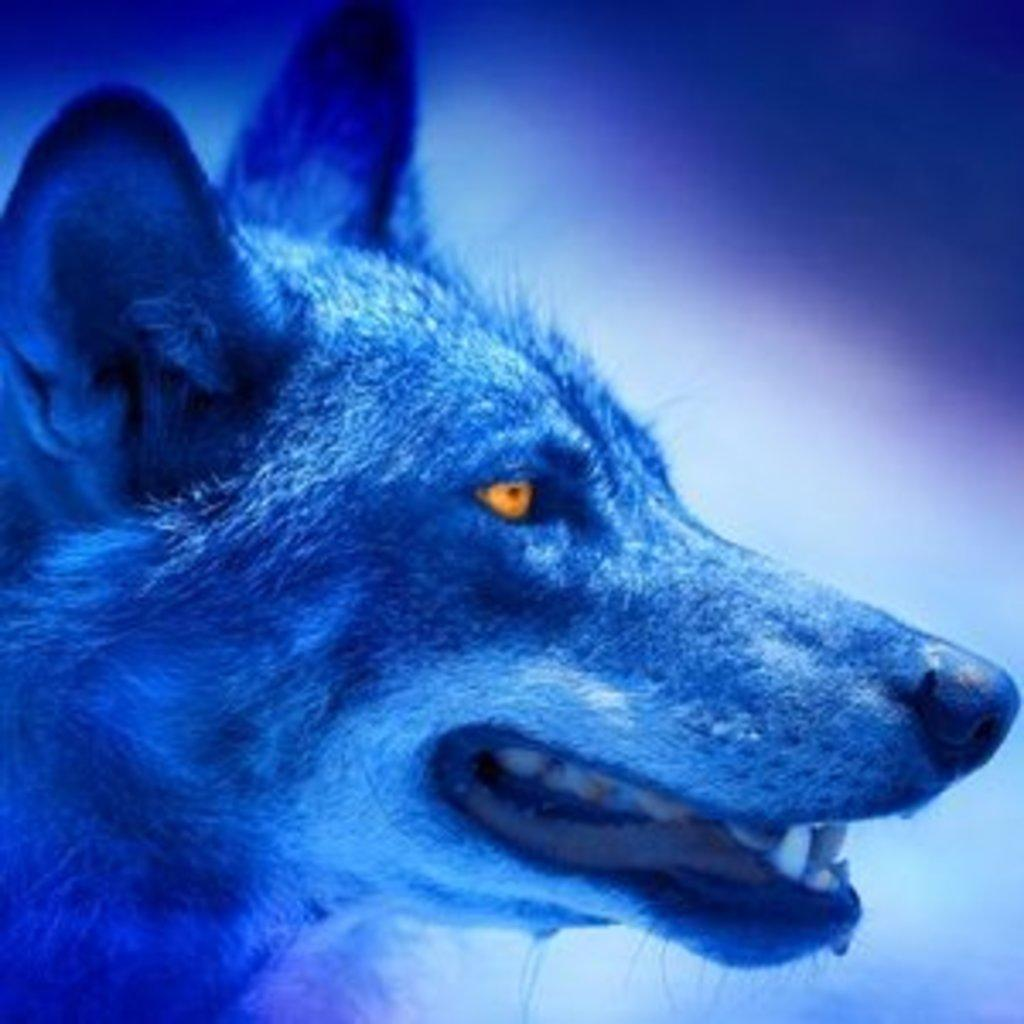What is the main subject of the image? The main subject of the image is a dog face. How is the dog face depicted in the image? The dog face is shown in a side view. What color light shade is present on the dog face? There is a blue color light shade on the dog face. What hobbies does the dog face have in the image? The image does not provide information about the dog face's hobbies, as it is a static image of a dog face. Can you describe how the dog face is acting in the image? The image is a still image, so the dog face is not actively "acting" in any way. 